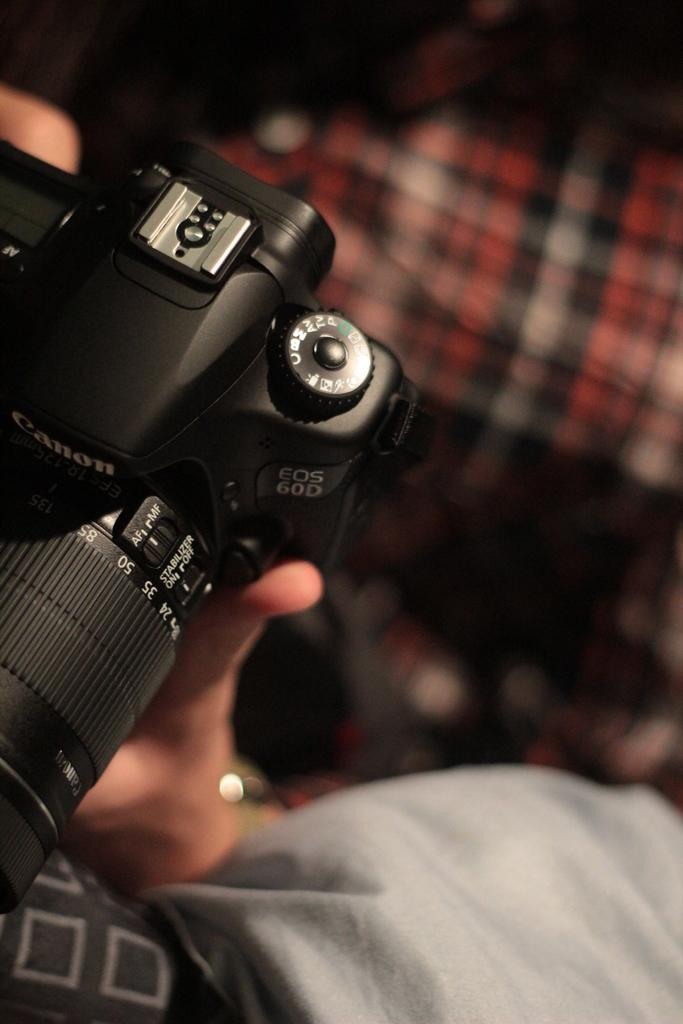What object is located at the left side of the image? There is a black camera at the left side of the image. What can be seen at the right side of the image? There is a blurred image at the right side of the image. Where is the sock placed in the image? There is no sock present in the image. What type of performance is happening on the stage in the image? There is no stage present in the image. 